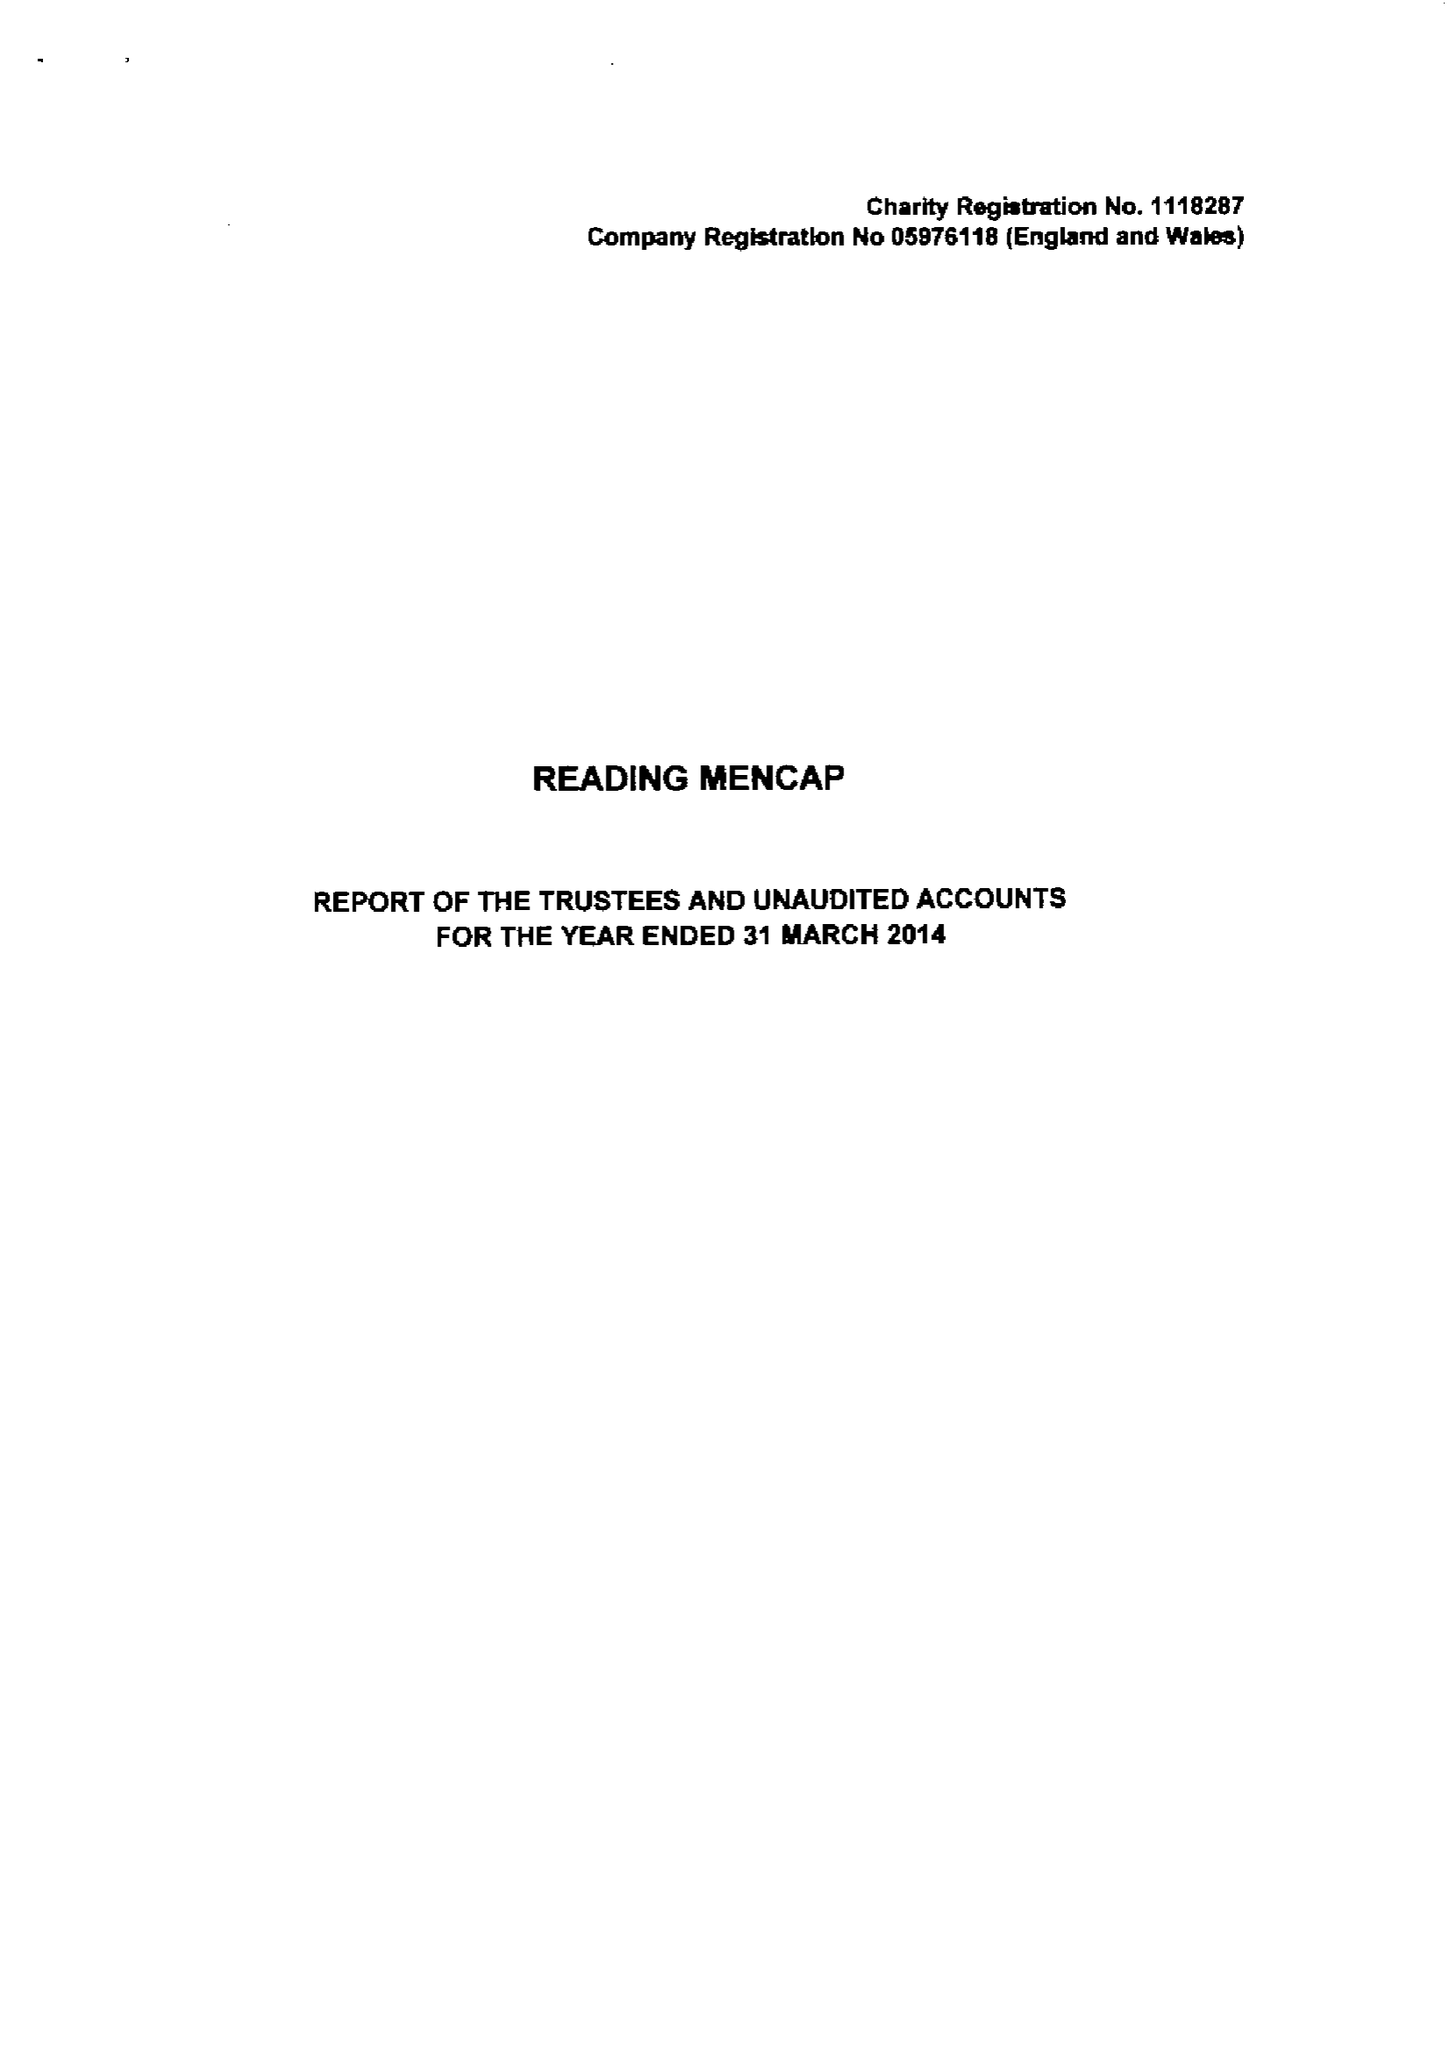What is the value for the address__postcode?
Answer the question using a single word or phrase. RG1 5PE 